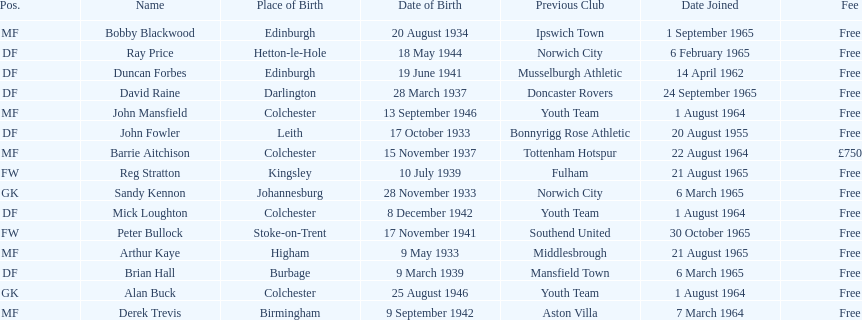Parse the table in full. {'header': ['Pos.', 'Name', 'Place of Birth', 'Date of Birth', 'Previous Club', 'Date Joined', 'Fee'], 'rows': [['MF', 'Bobby Blackwood', 'Edinburgh', '20 August 1934', 'Ipswich Town', '1 September 1965', 'Free'], ['DF', 'Ray Price', 'Hetton-le-Hole', '18 May 1944', 'Norwich City', '6 February 1965', 'Free'], ['DF', 'Duncan Forbes', 'Edinburgh', '19 June 1941', 'Musselburgh Athletic', '14 April 1962', 'Free'], ['DF', 'David Raine', 'Darlington', '28 March 1937', 'Doncaster Rovers', '24 September 1965', 'Free'], ['MF', 'John Mansfield', 'Colchester', '13 September 1946', 'Youth Team', '1 August 1964', 'Free'], ['DF', 'John Fowler', 'Leith', '17 October 1933', 'Bonnyrigg Rose Athletic', '20 August 1955', 'Free'], ['MF', 'Barrie Aitchison', 'Colchester', '15 November 1937', 'Tottenham Hotspur', '22 August 1964', '£750'], ['FW', 'Reg Stratton', 'Kingsley', '10 July 1939', 'Fulham', '21 August 1965', 'Free'], ['GK', 'Sandy Kennon', 'Johannesburg', '28 November 1933', 'Norwich City', '6 March 1965', 'Free'], ['DF', 'Mick Loughton', 'Colchester', '8 December 1942', 'Youth Team', '1 August 1964', 'Free'], ['FW', 'Peter Bullock', 'Stoke-on-Trent', '17 November 1941', 'Southend United', '30 October 1965', 'Free'], ['MF', 'Arthur Kaye', 'Higham', '9 May 1933', 'Middlesbrough', '21 August 1965', 'Free'], ['DF', 'Brian Hall', 'Burbage', '9 March 1939', 'Mansfield Town', '6 March 1965', 'Free'], ['GK', 'Alan Buck', 'Colchester', '25 August 1946', 'Youth Team', '1 August 1964', 'Free'], ['MF', 'Derek Trevis', 'Birmingham', '9 September 1942', 'Aston Villa', '7 March 1964', 'Free']]} Is arthur kaye older or younger than brian hill? Older. 